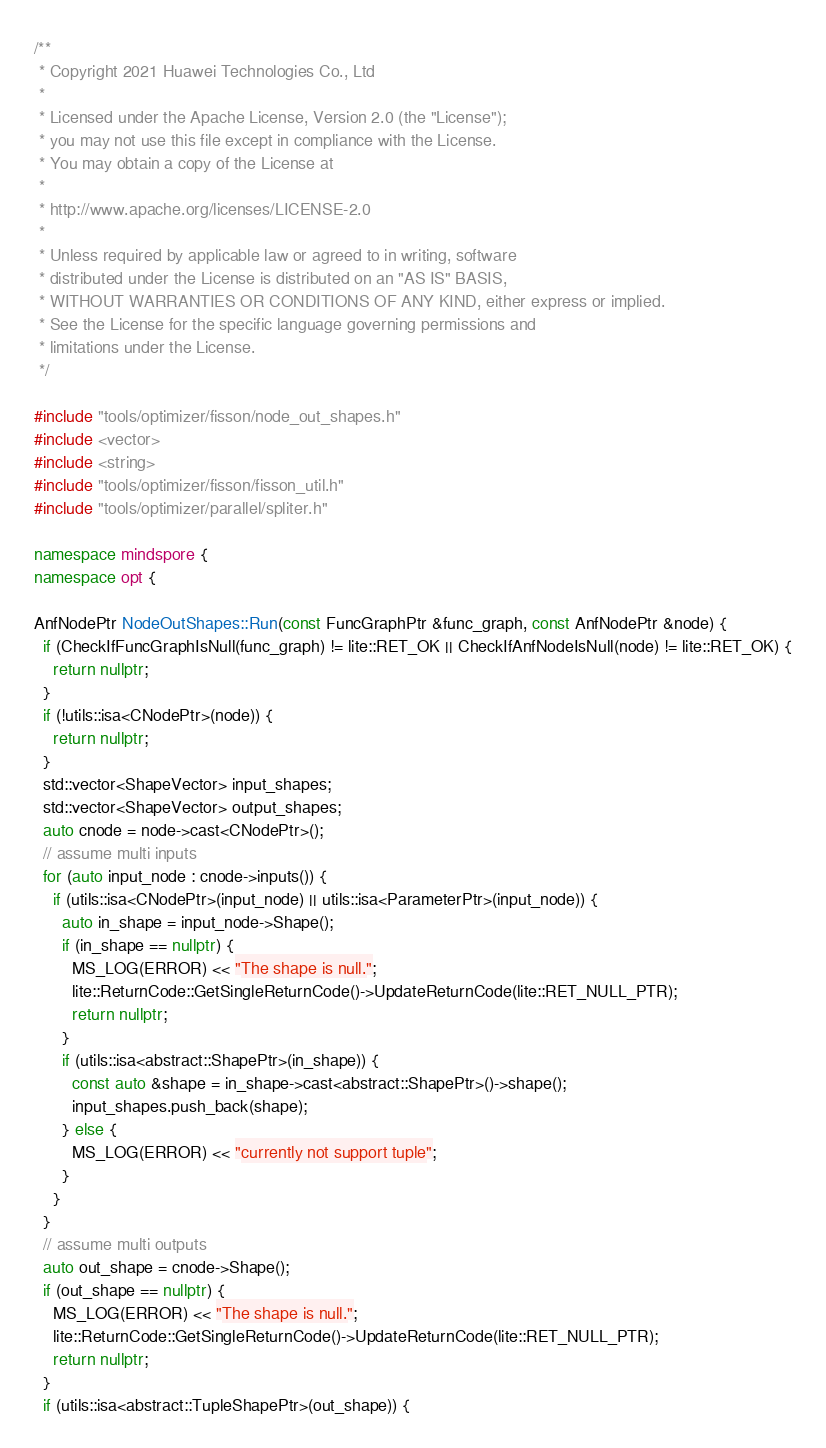<code> <loc_0><loc_0><loc_500><loc_500><_C++_>/**
 * Copyright 2021 Huawei Technologies Co., Ltd
 *
 * Licensed under the Apache License, Version 2.0 (the "License");
 * you may not use this file except in compliance with the License.
 * You may obtain a copy of the License at
 *
 * http://www.apache.org/licenses/LICENSE-2.0
 *
 * Unless required by applicable law or agreed to in writing, software
 * distributed under the License is distributed on an "AS IS" BASIS,
 * WITHOUT WARRANTIES OR CONDITIONS OF ANY KIND, either express or implied.
 * See the License for the specific language governing permissions and
 * limitations under the License.
 */

#include "tools/optimizer/fisson/node_out_shapes.h"
#include <vector>
#include <string>
#include "tools/optimizer/fisson/fisson_util.h"
#include "tools/optimizer/parallel/spliter.h"

namespace mindspore {
namespace opt {

AnfNodePtr NodeOutShapes::Run(const FuncGraphPtr &func_graph, const AnfNodePtr &node) {
  if (CheckIfFuncGraphIsNull(func_graph) != lite::RET_OK || CheckIfAnfNodeIsNull(node) != lite::RET_OK) {
    return nullptr;
  }
  if (!utils::isa<CNodePtr>(node)) {
    return nullptr;
  }
  std::vector<ShapeVector> input_shapes;
  std::vector<ShapeVector> output_shapes;
  auto cnode = node->cast<CNodePtr>();
  // assume multi inputs
  for (auto input_node : cnode->inputs()) {
    if (utils::isa<CNodePtr>(input_node) || utils::isa<ParameterPtr>(input_node)) {
      auto in_shape = input_node->Shape();
      if (in_shape == nullptr) {
        MS_LOG(ERROR) << "The shape is null.";
        lite::ReturnCode::GetSingleReturnCode()->UpdateReturnCode(lite::RET_NULL_PTR);
        return nullptr;
      }
      if (utils::isa<abstract::ShapePtr>(in_shape)) {
        const auto &shape = in_shape->cast<abstract::ShapePtr>()->shape();
        input_shapes.push_back(shape);
      } else {
        MS_LOG(ERROR) << "currently not support tuple";
      }
    }
  }
  // assume multi outputs
  auto out_shape = cnode->Shape();
  if (out_shape == nullptr) {
    MS_LOG(ERROR) << "The shape is null.";
    lite::ReturnCode::GetSingleReturnCode()->UpdateReturnCode(lite::RET_NULL_PTR);
    return nullptr;
  }
  if (utils::isa<abstract::TupleShapePtr>(out_shape)) {</code> 